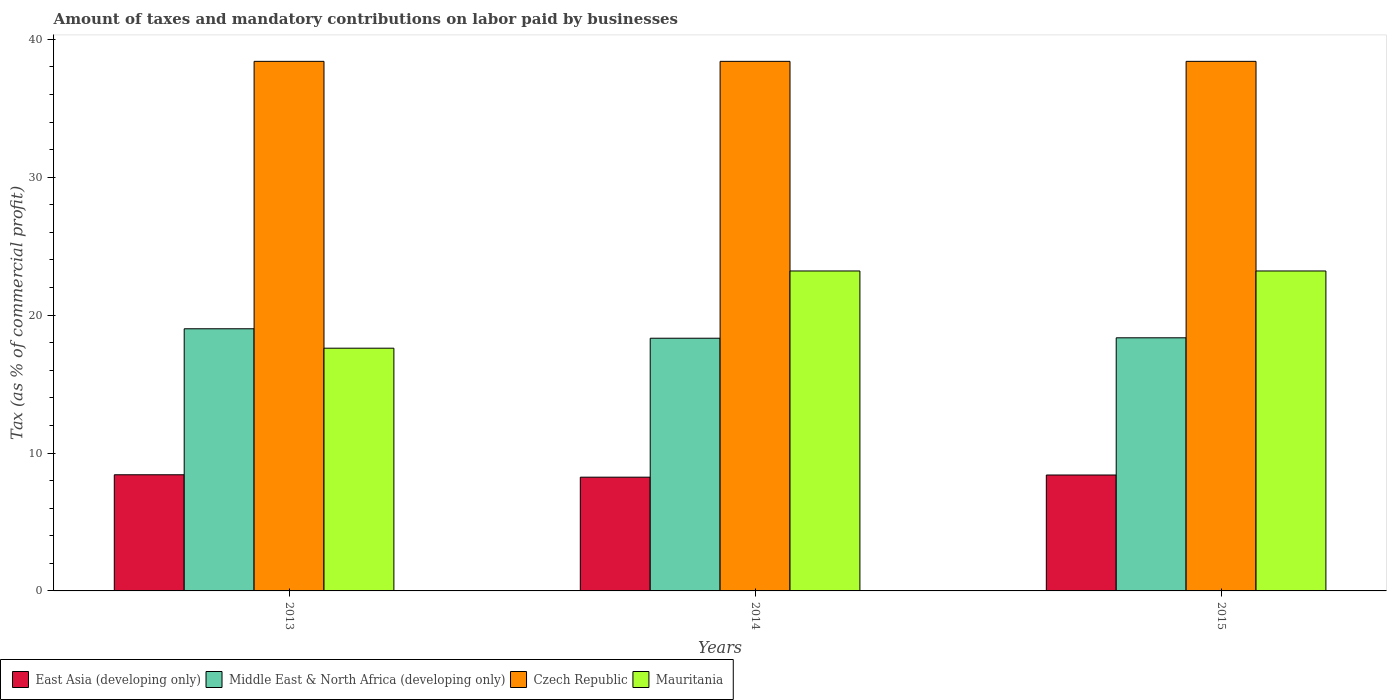How many different coloured bars are there?
Give a very brief answer. 4. How many groups of bars are there?
Ensure brevity in your answer.  3. Are the number of bars per tick equal to the number of legend labels?
Your answer should be compact. Yes. Are the number of bars on each tick of the X-axis equal?
Your answer should be very brief. Yes. How many bars are there on the 2nd tick from the right?
Make the answer very short. 4. In how many cases, is the number of bars for a given year not equal to the number of legend labels?
Keep it short and to the point. 0. What is the percentage of taxes paid by businesses in Middle East & North Africa (developing only) in 2015?
Your answer should be very brief. 18.35. Across all years, what is the maximum percentage of taxes paid by businesses in Czech Republic?
Give a very brief answer. 38.4. Across all years, what is the minimum percentage of taxes paid by businesses in Mauritania?
Offer a terse response. 17.6. What is the total percentage of taxes paid by businesses in Middle East & North Africa (developing only) in the graph?
Keep it short and to the point. 55.69. What is the difference between the percentage of taxes paid by businesses in Mauritania in 2013 and that in 2014?
Ensure brevity in your answer.  -5.6. What is the difference between the percentage of taxes paid by businesses in East Asia (developing only) in 2014 and the percentage of taxes paid by businesses in Middle East & North Africa (developing only) in 2013?
Your answer should be very brief. -10.76. What is the average percentage of taxes paid by businesses in Czech Republic per year?
Your answer should be very brief. 38.4. In the year 2014, what is the difference between the percentage of taxes paid by businesses in Czech Republic and percentage of taxes paid by businesses in East Asia (developing only)?
Your response must be concise. 30.15. In how many years, is the percentage of taxes paid by businesses in Mauritania greater than 6 %?
Make the answer very short. 3. What is the ratio of the percentage of taxes paid by businesses in Middle East & North Africa (developing only) in 2014 to that in 2015?
Ensure brevity in your answer.  1. Is the percentage of taxes paid by businesses in Czech Republic in 2013 less than that in 2015?
Give a very brief answer. No. Is the difference between the percentage of taxes paid by businesses in Czech Republic in 2013 and 2014 greater than the difference between the percentage of taxes paid by businesses in East Asia (developing only) in 2013 and 2014?
Offer a terse response. No. What is the difference between the highest and the lowest percentage of taxes paid by businesses in Mauritania?
Make the answer very short. 5.6. In how many years, is the percentage of taxes paid by businesses in Middle East & North Africa (developing only) greater than the average percentage of taxes paid by businesses in Middle East & North Africa (developing only) taken over all years?
Provide a short and direct response. 1. Is the sum of the percentage of taxes paid by businesses in East Asia (developing only) in 2014 and 2015 greater than the maximum percentage of taxes paid by businesses in Mauritania across all years?
Offer a very short reply. No. What does the 1st bar from the left in 2015 represents?
Offer a very short reply. East Asia (developing only). What does the 4th bar from the right in 2015 represents?
Offer a terse response. East Asia (developing only). Is it the case that in every year, the sum of the percentage of taxes paid by businesses in Mauritania and percentage of taxes paid by businesses in Czech Republic is greater than the percentage of taxes paid by businesses in Middle East & North Africa (developing only)?
Offer a terse response. Yes. How many bars are there?
Offer a very short reply. 12. Are all the bars in the graph horizontal?
Offer a very short reply. No. How many years are there in the graph?
Give a very brief answer. 3. What is the difference between two consecutive major ticks on the Y-axis?
Your answer should be very brief. 10. How many legend labels are there?
Offer a very short reply. 4. How are the legend labels stacked?
Your answer should be compact. Horizontal. What is the title of the graph?
Offer a terse response. Amount of taxes and mandatory contributions on labor paid by businesses. Does "Greenland" appear as one of the legend labels in the graph?
Provide a short and direct response. No. What is the label or title of the X-axis?
Ensure brevity in your answer.  Years. What is the label or title of the Y-axis?
Your answer should be compact. Tax (as % of commercial profit). What is the Tax (as % of commercial profit) of East Asia (developing only) in 2013?
Provide a succinct answer. 8.42. What is the Tax (as % of commercial profit) in Middle East & North Africa (developing only) in 2013?
Offer a terse response. 19.01. What is the Tax (as % of commercial profit) of Czech Republic in 2013?
Provide a short and direct response. 38.4. What is the Tax (as % of commercial profit) in East Asia (developing only) in 2014?
Your answer should be very brief. 8.25. What is the Tax (as % of commercial profit) in Middle East & North Africa (developing only) in 2014?
Keep it short and to the point. 18.32. What is the Tax (as % of commercial profit) of Czech Republic in 2014?
Ensure brevity in your answer.  38.4. What is the Tax (as % of commercial profit) in Mauritania in 2014?
Ensure brevity in your answer.  23.2. What is the Tax (as % of commercial profit) of East Asia (developing only) in 2015?
Provide a short and direct response. 8.41. What is the Tax (as % of commercial profit) of Middle East & North Africa (developing only) in 2015?
Provide a succinct answer. 18.35. What is the Tax (as % of commercial profit) of Czech Republic in 2015?
Offer a terse response. 38.4. What is the Tax (as % of commercial profit) of Mauritania in 2015?
Your answer should be very brief. 23.2. Across all years, what is the maximum Tax (as % of commercial profit) of East Asia (developing only)?
Make the answer very short. 8.42. Across all years, what is the maximum Tax (as % of commercial profit) in Middle East & North Africa (developing only)?
Your answer should be very brief. 19.01. Across all years, what is the maximum Tax (as % of commercial profit) in Czech Republic?
Make the answer very short. 38.4. Across all years, what is the maximum Tax (as % of commercial profit) in Mauritania?
Offer a very short reply. 23.2. Across all years, what is the minimum Tax (as % of commercial profit) of East Asia (developing only)?
Make the answer very short. 8.25. Across all years, what is the minimum Tax (as % of commercial profit) of Middle East & North Africa (developing only)?
Give a very brief answer. 18.32. Across all years, what is the minimum Tax (as % of commercial profit) of Czech Republic?
Provide a short and direct response. 38.4. Across all years, what is the minimum Tax (as % of commercial profit) in Mauritania?
Offer a very short reply. 17.6. What is the total Tax (as % of commercial profit) in East Asia (developing only) in the graph?
Offer a terse response. 25.07. What is the total Tax (as % of commercial profit) in Middle East & North Africa (developing only) in the graph?
Give a very brief answer. 55.69. What is the total Tax (as % of commercial profit) in Czech Republic in the graph?
Give a very brief answer. 115.2. What is the total Tax (as % of commercial profit) of Mauritania in the graph?
Give a very brief answer. 64. What is the difference between the Tax (as % of commercial profit) in East Asia (developing only) in 2013 and that in 2014?
Provide a succinct answer. 0.17. What is the difference between the Tax (as % of commercial profit) in Middle East & North Africa (developing only) in 2013 and that in 2014?
Keep it short and to the point. 0.69. What is the difference between the Tax (as % of commercial profit) of Mauritania in 2013 and that in 2014?
Your response must be concise. -5.6. What is the difference between the Tax (as % of commercial profit) in East Asia (developing only) in 2013 and that in 2015?
Offer a terse response. 0.02. What is the difference between the Tax (as % of commercial profit) of Middle East & North Africa (developing only) in 2013 and that in 2015?
Your response must be concise. 0.65. What is the difference between the Tax (as % of commercial profit) of Czech Republic in 2013 and that in 2015?
Make the answer very short. 0. What is the difference between the Tax (as % of commercial profit) of East Asia (developing only) in 2014 and that in 2015?
Make the answer very short. -0.16. What is the difference between the Tax (as % of commercial profit) of Middle East & North Africa (developing only) in 2014 and that in 2015?
Provide a succinct answer. -0.03. What is the difference between the Tax (as % of commercial profit) in Czech Republic in 2014 and that in 2015?
Keep it short and to the point. 0. What is the difference between the Tax (as % of commercial profit) of Mauritania in 2014 and that in 2015?
Make the answer very short. 0. What is the difference between the Tax (as % of commercial profit) in East Asia (developing only) in 2013 and the Tax (as % of commercial profit) in Middle East & North Africa (developing only) in 2014?
Ensure brevity in your answer.  -9.9. What is the difference between the Tax (as % of commercial profit) in East Asia (developing only) in 2013 and the Tax (as % of commercial profit) in Czech Republic in 2014?
Your response must be concise. -29.98. What is the difference between the Tax (as % of commercial profit) of East Asia (developing only) in 2013 and the Tax (as % of commercial profit) of Mauritania in 2014?
Your answer should be very brief. -14.78. What is the difference between the Tax (as % of commercial profit) of Middle East & North Africa (developing only) in 2013 and the Tax (as % of commercial profit) of Czech Republic in 2014?
Your response must be concise. -19.39. What is the difference between the Tax (as % of commercial profit) in Middle East & North Africa (developing only) in 2013 and the Tax (as % of commercial profit) in Mauritania in 2014?
Provide a short and direct response. -4.19. What is the difference between the Tax (as % of commercial profit) of East Asia (developing only) in 2013 and the Tax (as % of commercial profit) of Middle East & North Africa (developing only) in 2015?
Your response must be concise. -9.93. What is the difference between the Tax (as % of commercial profit) of East Asia (developing only) in 2013 and the Tax (as % of commercial profit) of Czech Republic in 2015?
Ensure brevity in your answer.  -29.98. What is the difference between the Tax (as % of commercial profit) in East Asia (developing only) in 2013 and the Tax (as % of commercial profit) in Mauritania in 2015?
Your answer should be compact. -14.78. What is the difference between the Tax (as % of commercial profit) of Middle East & North Africa (developing only) in 2013 and the Tax (as % of commercial profit) of Czech Republic in 2015?
Provide a short and direct response. -19.39. What is the difference between the Tax (as % of commercial profit) of Middle East & North Africa (developing only) in 2013 and the Tax (as % of commercial profit) of Mauritania in 2015?
Ensure brevity in your answer.  -4.19. What is the difference between the Tax (as % of commercial profit) in Czech Republic in 2013 and the Tax (as % of commercial profit) in Mauritania in 2015?
Give a very brief answer. 15.2. What is the difference between the Tax (as % of commercial profit) in East Asia (developing only) in 2014 and the Tax (as % of commercial profit) in Middle East & North Africa (developing only) in 2015?
Keep it short and to the point. -10.11. What is the difference between the Tax (as % of commercial profit) of East Asia (developing only) in 2014 and the Tax (as % of commercial profit) of Czech Republic in 2015?
Make the answer very short. -30.15. What is the difference between the Tax (as % of commercial profit) of East Asia (developing only) in 2014 and the Tax (as % of commercial profit) of Mauritania in 2015?
Provide a succinct answer. -14.95. What is the difference between the Tax (as % of commercial profit) of Middle East & North Africa (developing only) in 2014 and the Tax (as % of commercial profit) of Czech Republic in 2015?
Keep it short and to the point. -20.08. What is the difference between the Tax (as % of commercial profit) in Middle East & North Africa (developing only) in 2014 and the Tax (as % of commercial profit) in Mauritania in 2015?
Offer a very short reply. -4.88. What is the difference between the Tax (as % of commercial profit) in Czech Republic in 2014 and the Tax (as % of commercial profit) in Mauritania in 2015?
Your answer should be very brief. 15.2. What is the average Tax (as % of commercial profit) of East Asia (developing only) per year?
Keep it short and to the point. 8.36. What is the average Tax (as % of commercial profit) in Middle East & North Africa (developing only) per year?
Offer a very short reply. 18.56. What is the average Tax (as % of commercial profit) in Czech Republic per year?
Your answer should be compact. 38.4. What is the average Tax (as % of commercial profit) in Mauritania per year?
Make the answer very short. 21.33. In the year 2013, what is the difference between the Tax (as % of commercial profit) of East Asia (developing only) and Tax (as % of commercial profit) of Middle East & North Africa (developing only)?
Make the answer very short. -10.59. In the year 2013, what is the difference between the Tax (as % of commercial profit) in East Asia (developing only) and Tax (as % of commercial profit) in Czech Republic?
Ensure brevity in your answer.  -29.98. In the year 2013, what is the difference between the Tax (as % of commercial profit) of East Asia (developing only) and Tax (as % of commercial profit) of Mauritania?
Offer a very short reply. -9.18. In the year 2013, what is the difference between the Tax (as % of commercial profit) in Middle East & North Africa (developing only) and Tax (as % of commercial profit) in Czech Republic?
Ensure brevity in your answer.  -19.39. In the year 2013, what is the difference between the Tax (as % of commercial profit) of Middle East & North Africa (developing only) and Tax (as % of commercial profit) of Mauritania?
Provide a short and direct response. 1.41. In the year 2013, what is the difference between the Tax (as % of commercial profit) in Czech Republic and Tax (as % of commercial profit) in Mauritania?
Provide a succinct answer. 20.8. In the year 2014, what is the difference between the Tax (as % of commercial profit) of East Asia (developing only) and Tax (as % of commercial profit) of Middle East & North Africa (developing only)?
Your response must be concise. -10.08. In the year 2014, what is the difference between the Tax (as % of commercial profit) of East Asia (developing only) and Tax (as % of commercial profit) of Czech Republic?
Your answer should be very brief. -30.15. In the year 2014, what is the difference between the Tax (as % of commercial profit) in East Asia (developing only) and Tax (as % of commercial profit) in Mauritania?
Provide a short and direct response. -14.95. In the year 2014, what is the difference between the Tax (as % of commercial profit) in Middle East & North Africa (developing only) and Tax (as % of commercial profit) in Czech Republic?
Keep it short and to the point. -20.08. In the year 2014, what is the difference between the Tax (as % of commercial profit) in Middle East & North Africa (developing only) and Tax (as % of commercial profit) in Mauritania?
Your answer should be very brief. -4.88. In the year 2014, what is the difference between the Tax (as % of commercial profit) of Czech Republic and Tax (as % of commercial profit) of Mauritania?
Ensure brevity in your answer.  15.2. In the year 2015, what is the difference between the Tax (as % of commercial profit) in East Asia (developing only) and Tax (as % of commercial profit) in Middle East & North Africa (developing only)?
Your answer should be very brief. -9.95. In the year 2015, what is the difference between the Tax (as % of commercial profit) in East Asia (developing only) and Tax (as % of commercial profit) in Czech Republic?
Provide a short and direct response. -29.99. In the year 2015, what is the difference between the Tax (as % of commercial profit) in East Asia (developing only) and Tax (as % of commercial profit) in Mauritania?
Your answer should be compact. -14.79. In the year 2015, what is the difference between the Tax (as % of commercial profit) of Middle East & North Africa (developing only) and Tax (as % of commercial profit) of Czech Republic?
Make the answer very short. -20.05. In the year 2015, what is the difference between the Tax (as % of commercial profit) of Middle East & North Africa (developing only) and Tax (as % of commercial profit) of Mauritania?
Offer a terse response. -4.85. In the year 2015, what is the difference between the Tax (as % of commercial profit) in Czech Republic and Tax (as % of commercial profit) in Mauritania?
Make the answer very short. 15.2. What is the ratio of the Tax (as % of commercial profit) of East Asia (developing only) in 2013 to that in 2014?
Keep it short and to the point. 1.02. What is the ratio of the Tax (as % of commercial profit) of Middle East & North Africa (developing only) in 2013 to that in 2014?
Your answer should be very brief. 1.04. What is the ratio of the Tax (as % of commercial profit) of Czech Republic in 2013 to that in 2014?
Provide a succinct answer. 1. What is the ratio of the Tax (as % of commercial profit) in Mauritania in 2013 to that in 2014?
Your answer should be very brief. 0.76. What is the ratio of the Tax (as % of commercial profit) of East Asia (developing only) in 2013 to that in 2015?
Provide a short and direct response. 1. What is the ratio of the Tax (as % of commercial profit) of Middle East & North Africa (developing only) in 2013 to that in 2015?
Keep it short and to the point. 1.04. What is the ratio of the Tax (as % of commercial profit) in Czech Republic in 2013 to that in 2015?
Keep it short and to the point. 1. What is the ratio of the Tax (as % of commercial profit) of Mauritania in 2013 to that in 2015?
Make the answer very short. 0.76. What is the ratio of the Tax (as % of commercial profit) of East Asia (developing only) in 2014 to that in 2015?
Offer a terse response. 0.98. What is the ratio of the Tax (as % of commercial profit) in Middle East & North Africa (developing only) in 2014 to that in 2015?
Provide a succinct answer. 1. What is the ratio of the Tax (as % of commercial profit) in Czech Republic in 2014 to that in 2015?
Provide a short and direct response. 1. What is the difference between the highest and the second highest Tax (as % of commercial profit) of East Asia (developing only)?
Give a very brief answer. 0.02. What is the difference between the highest and the second highest Tax (as % of commercial profit) of Middle East & North Africa (developing only)?
Your response must be concise. 0.65. What is the difference between the highest and the second highest Tax (as % of commercial profit) in Mauritania?
Provide a short and direct response. 0. What is the difference between the highest and the lowest Tax (as % of commercial profit) in East Asia (developing only)?
Keep it short and to the point. 0.17. What is the difference between the highest and the lowest Tax (as % of commercial profit) in Middle East & North Africa (developing only)?
Your response must be concise. 0.69. What is the difference between the highest and the lowest Tax (as % of commercial profit) of Mauritania?
Offer a terse response. 5.6. 